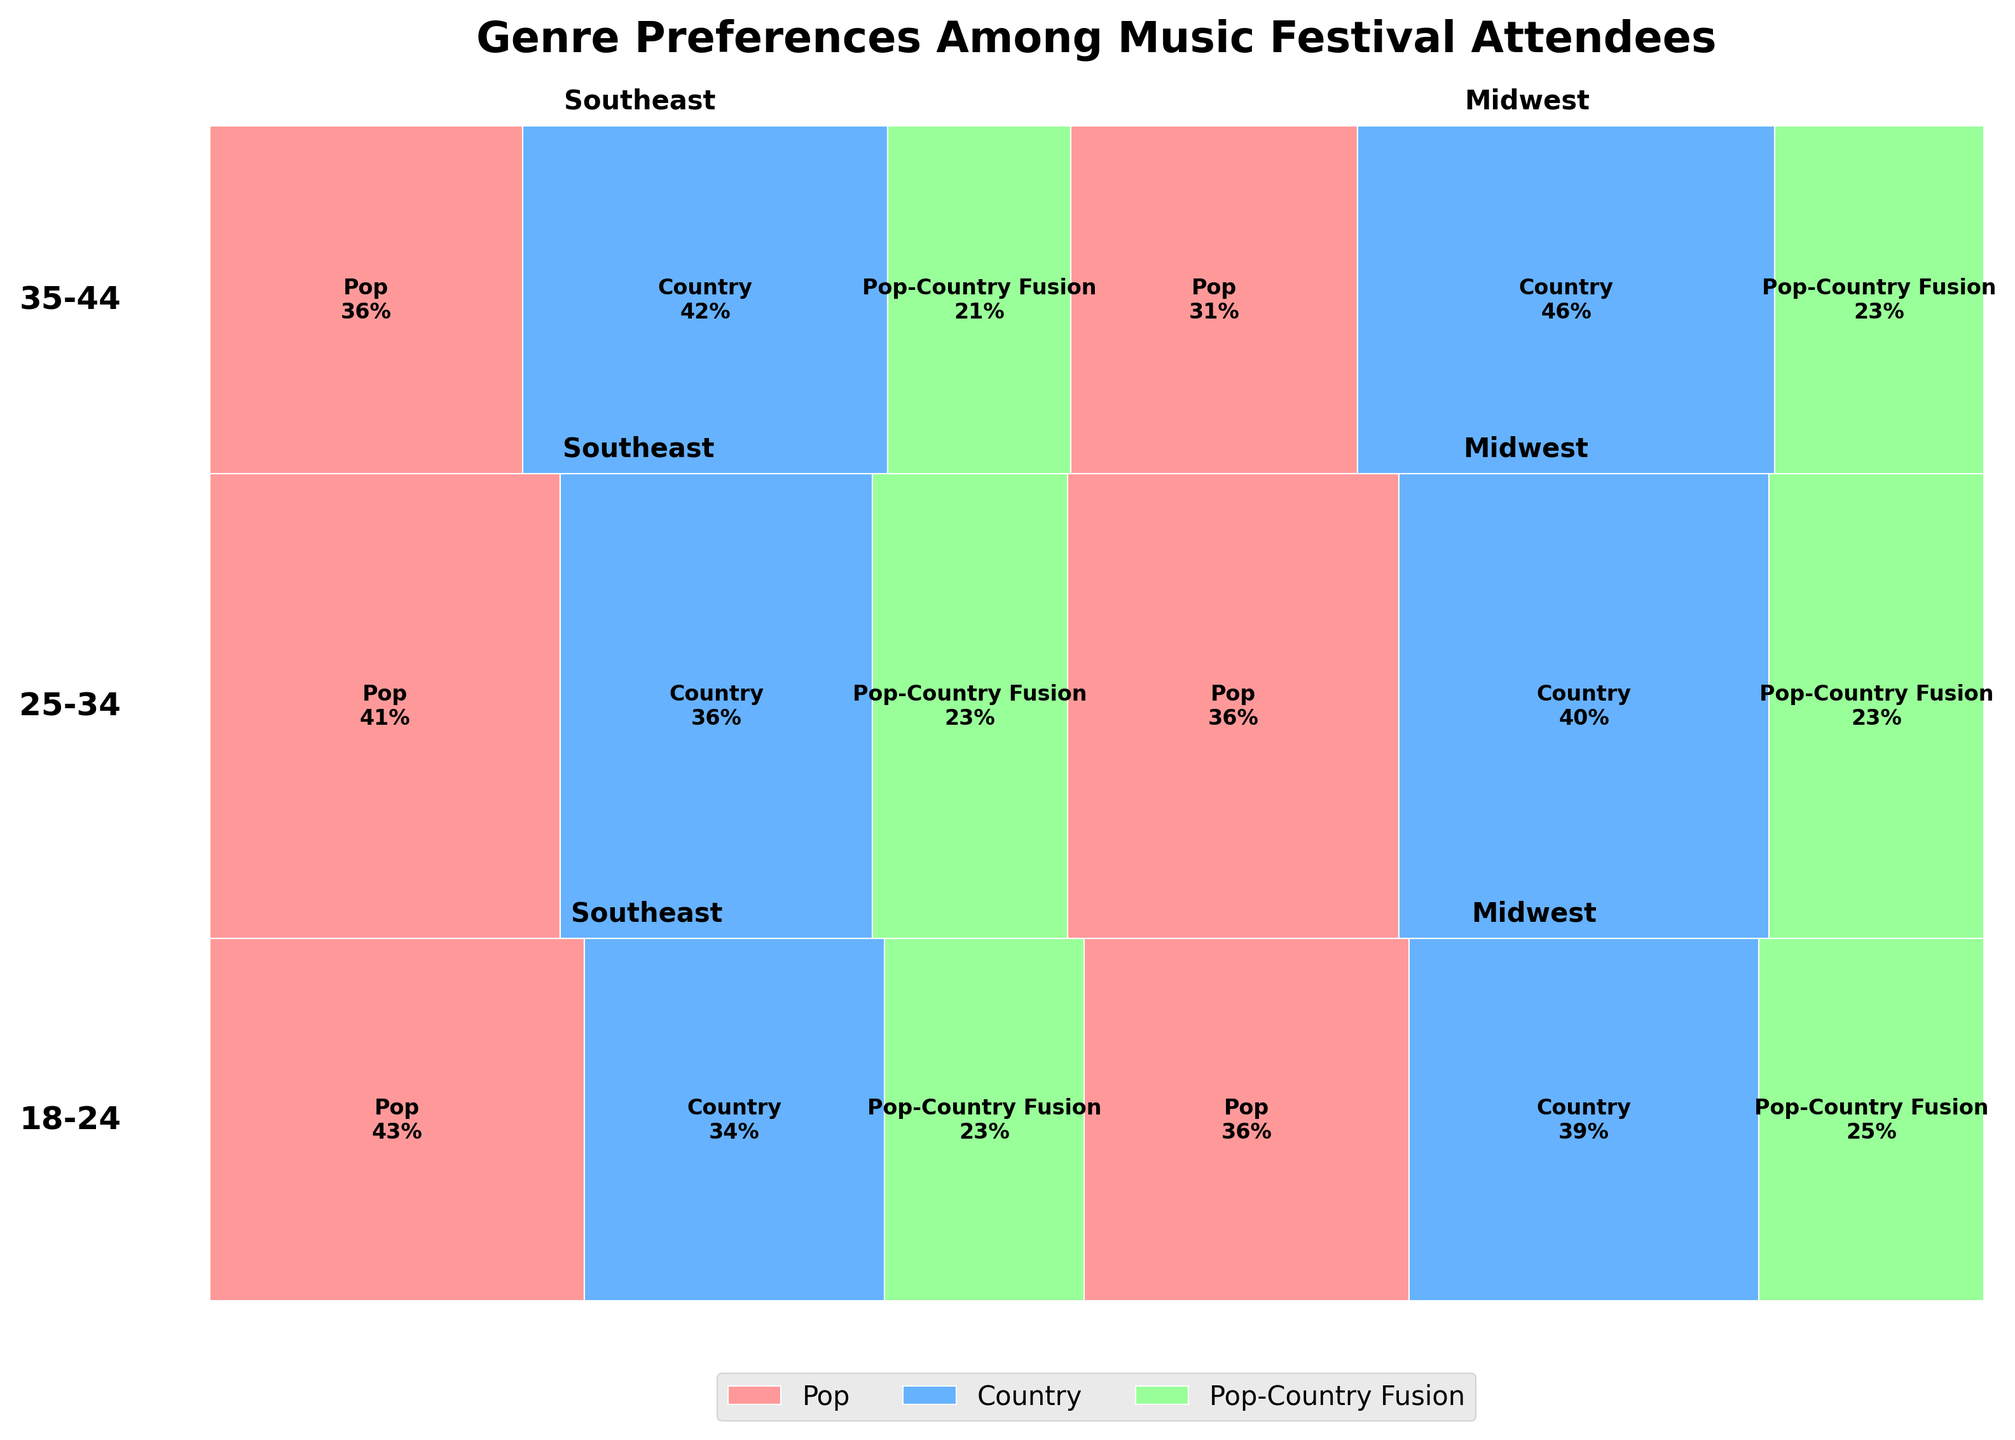What age group has the highest representation of Pop-Country Fusion fans in the Southeast region? To determine this, locate the sections representing Pop-Country Fusion fans in the Southeast for each age group and compare their sizes.
Answer: 25-34 Which music genre is generally more popular among 18-24-year-olds in the Midwest, Pop or Country? Find the sections representing Pop and Country within the Midwest region for the 18-24 age group and compare their sizes.
Answer: Country What is the overall proportion of Country music fans among 35-44-year-olds in the Midwest and Southeast regions combined? Add up the counts of Country fans for the 35-44 age group in both regions and divide by the total count of 35-44-year-olds in these regions.
Answer: 50% How does the preference for Pop music in the Southeast change as the age group progresses from 18-24 to 35-44? Compare the size of the Pop sections in the Southeast for age groups 18-24, 25-34, and 35-44.
Answer: Decreases Which region shows a higher proportion of Pop-Country Fusion fans among those aged 25-34, the Southeast or Midwest? Compare the sections representing Pop-Country Fusion fans for those aged 25-34 in both regions to determine which is larger.
Answer: Midwest Among all age groups, which region has the highest number of Country music fans? Sum up the sections representing Country fans across all age groups within each region and compare the totals.
Answer: Midwest Are there any age groups where the Pop-Country Fusion genre is more popular than either Pop or Country alone in any region? For each age group and region, compare the size of the Pop-Country Fusion sections to the Pop and Country sections.
Answer: No 